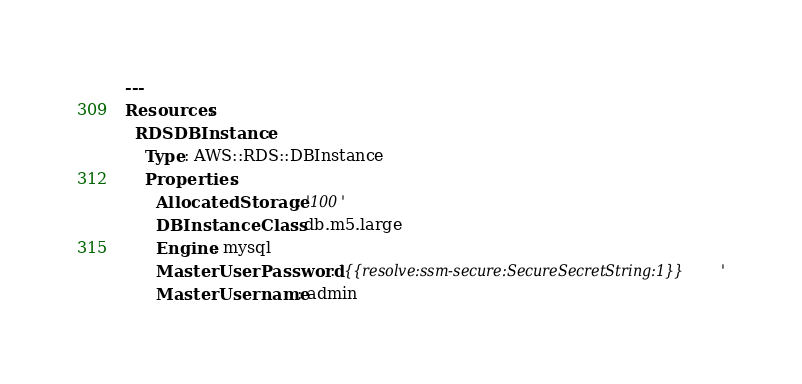Convert code to text. <code><loc_0><loc_0><loc_500><loc_500><_YAML_>---
Resources:
  RDSDBInstance:
    Type: AWS::RDS::DBInstance
    Properties:
      AllocatedStorage: '100'
      DBInstanceClass: db.m5.large
      Engine: mysql
      MasterUserPassword: '{{resolve:ssm-secure:SecureSecretString:1}}'
      MasterUsername: admin
</code> 